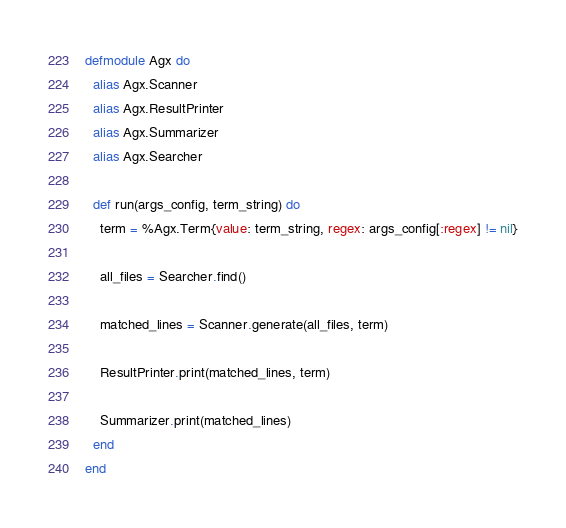<code> <loc_0><loc_0><loc_500><loc_500><_Elixir_>defmodule Agx do
  alias Agx.Scanner
  alias Agx.ResultPrinter
  alias Agx.Summarizer
  alias Agx.Searcher

  def run(args_config, term_string) do
    term = %Agx.Term{value: term_string, regex: args_config[:regex] != nil}

    all_files = Searcher.find()

    matched_lines = Scanner.generate(all_files, term)

    ResultPrinter.print(matched_lines, term)

    Summarizer.print(matched_lines)
  end
end
</code> 